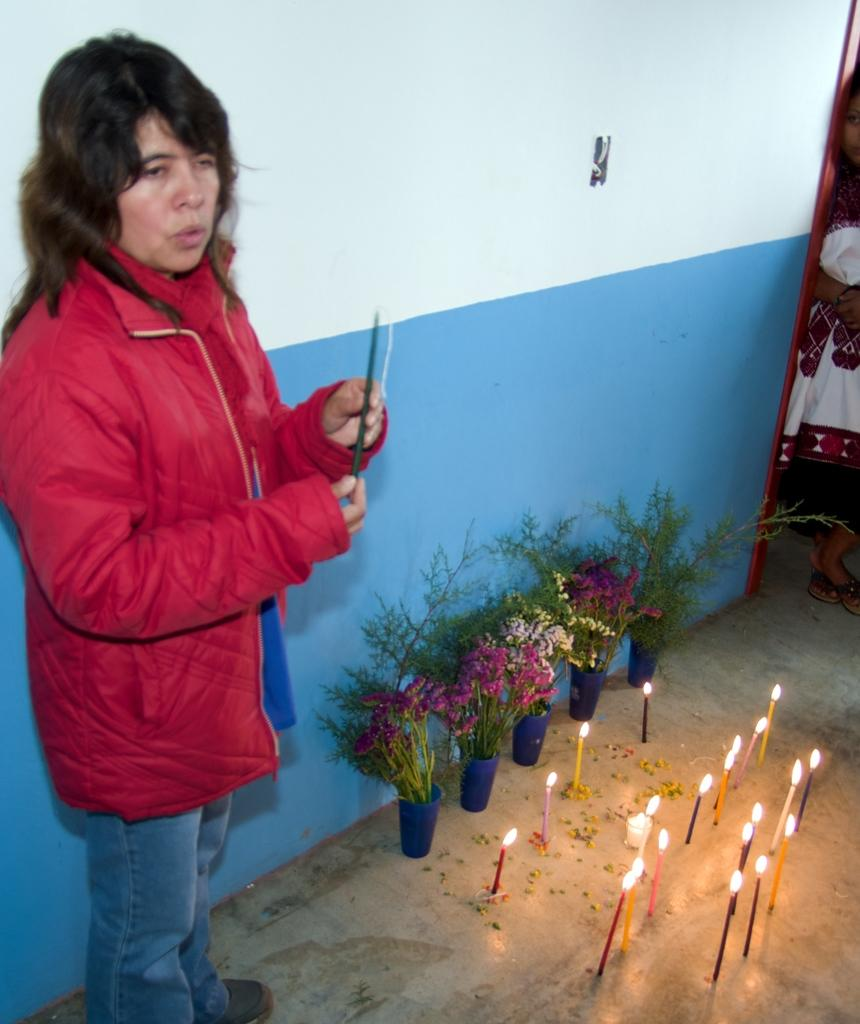What is the main subject in the foreground of the image? There is a woman standing in the foreground of the image. What objects can be seen on the floor in the image? There are plant pots and candles on the floor. Can you describe the background of the image? There is another person in the background of the image. What type of belief is being practiced by the woman in the image? There is no indication of any belief being practiced in the image; it only shows a woman standing with plant pots and candles on the floor. What kind of beef dish is being prepared in the image? There is no beef dish or any food preparation visible in the image. 